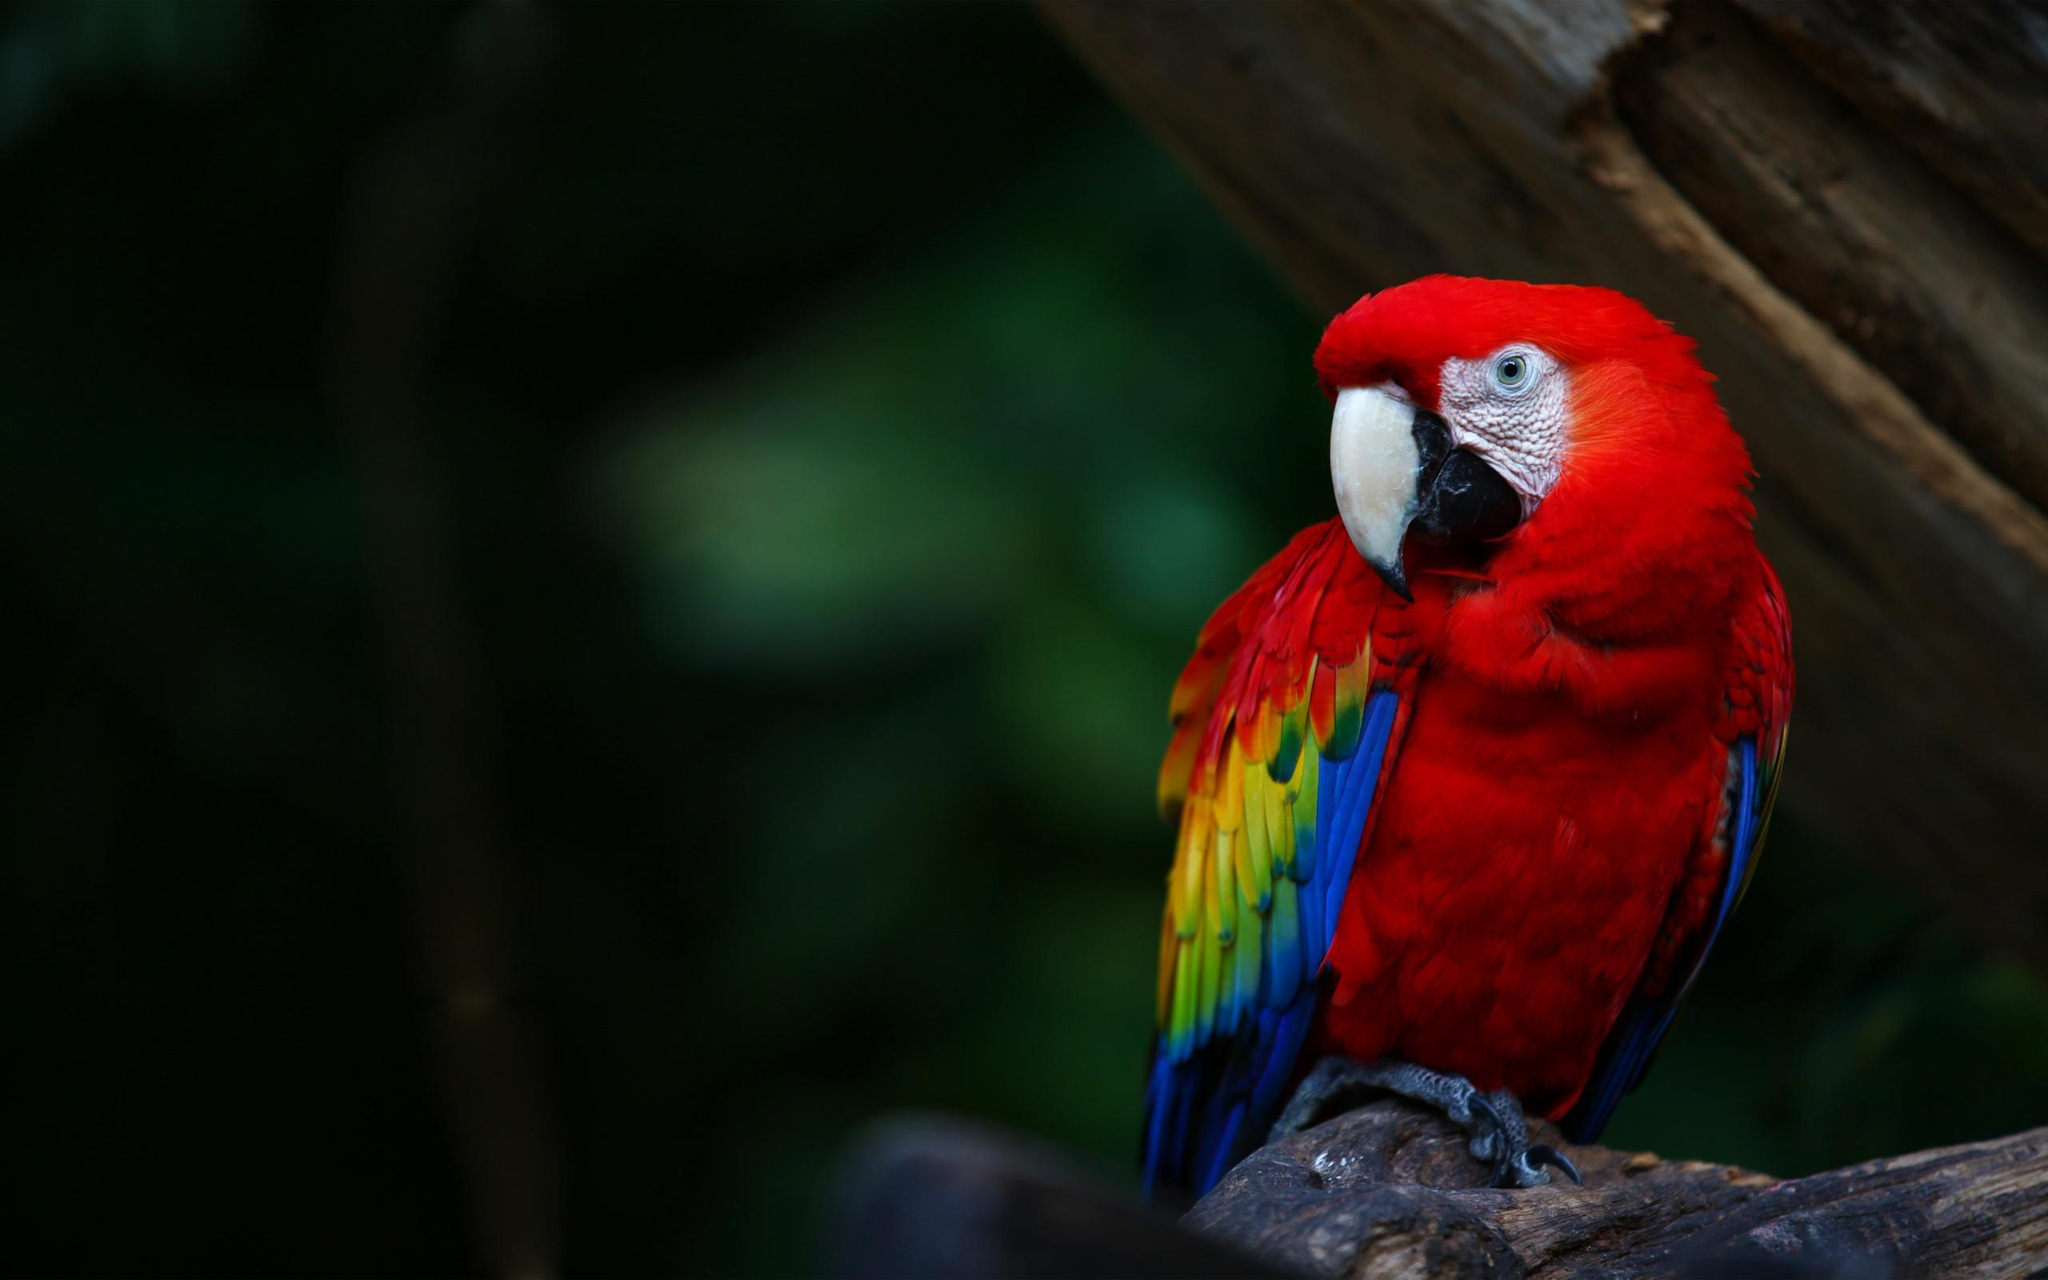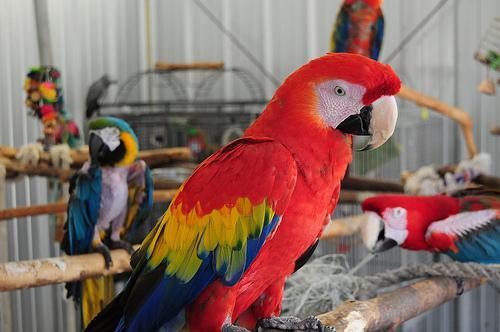The first image is the image on the left, the second image is the image on the right. Evaluate the accuracy of this statement regarding the images: "Each image shows a red-headed bird with its face in profile and its eye shut.". Is it true? Answer yes or no. No. The first image is the image on the left, the second image is the image on the right. Evaluate the accuracy of this statement regarding the images: "The bird in the image on the right has its eyes closed.". Is it true? Answer yes or no. No. 